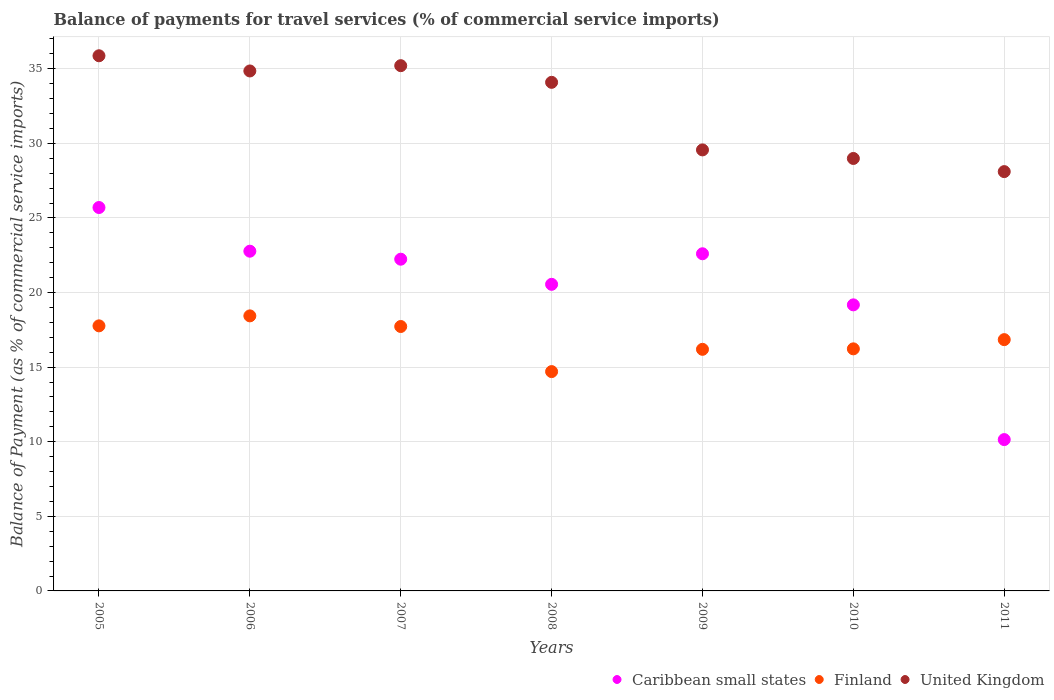How many different coloured dotlines are there?
Offer a terse response. 3. Is the number of dotlines equal to the number of legend labels?
Offer a terse response. Yes. What is the balance of payments for travel services in United Kingdom in 2006?
Ensure brevity in your answer.  34.86. Across all years, what is the maximum balance of payments for travel services in Caribbean small states?
Offer a terse response. 25.7. Across all years, what is the minimum balance of payments for travel services in Caribbean small states?
Your response must be concise. 10.14. In which year was the balance of payments for travel services in United Kingdom maximum?
Provide a short and direct response. 2005. What is the total balance of payments for travel services in United Kingdom in the graph?
Offer a very short reply. 226.7. What is the difference between the balance of payments for travel services in Finland in 2005 and that in 2008?
Your answer should be compact. 3.07. What is the difference between the balance of payments for travel services in Finland in 2006 and the balance of payments for travel services in Caribbean small states in 2010?
Offer a very short reply. -0.74. What is the average balance of payments for travel services in Finland per year?
Offer a very short reply. 16.84. In the year 2008, what is the difference between the balance of payments for travel services in Finland and balance of payments for travel services in United Kingdom?
Make the answer very short. -19.39. In how many years, is the balance of payments for travel services in Finland greater than 31 %?
Ensure brevity in your answer.  0. What is the ratio of the balance of payments for travel services in Caribbean small states in 2006 to that in 2010?
Provide a succinct answer. 1.19. What is the difference between the highest and the second highest balance of payments for travel services in United Kingdom?
Your answer should be compact. 0.66. What is the difference between the highest and the lowest balance of payments for travel services in Finland?
Ensure brevity in your answer.  3.74. In how many years, is the balance of payments for travel services in United Kingdom greater than the average balance of payments for travel services in United Kingdom taken over all years?
Ensure brevity in your answer.  4. Is the sum of the balance of payments for travel services in Caribbean small states in 2009 and 2010 greater than the maximum balance of payments for travel services in United Kingdom across all years?
Offer a very short reply. Yes. Does the balance of payments for travel services in United Kingdom monotonically increase over the years?
Make the answer very short. No. How many dotlines are there?
Offer a terse response. 3. Are the values on the major ticks of Y-axis written in scientific E-notation?
Make the answer very short. No. Does the graph contain grids?
Your answer should be compact. Yes. Where does the legend appear in the graph?
Provide a short and direct response. Bottom right. What is the title of the graph?
Provide a short and direct response. Balance of payments for travel services (% of commercial service imports). Does "Tajikistan" appear as one of the legend labels in the graph?
Your answer should be very brief. No. What is the label or title of the Y-axis?
Give a very brief answer. Balance of Payment (as % of commercial service imports). What is the Balance of Payment (as % of commercial service imports) of Caribbean small states in 2005?
Provide a short and direct response. 25.7. What is the Balance of Payment (as % of commercial service imports) in Finland in 2005?
Make the answer very short. 17.77. What is the Balance of Payment (as % of commercial service imports) of United Kingdom in 2005?
Provide a succinct answer. 35.87. What is the Balance of Payment (as % of commercial service imports) in Caribbean small states in 2006?
Ensure brevity in your answer.  22.77. What is the Balance of Payment (as % of commercial service imports) of Finland in 2006?
Keep it short and to the point. 18.44. What is the Balance of Payment (as % of commercial service imports) in United Kingdom in 2006?
Offer a terse response. 34.86. What is the Balance of Payment (as % of commercial service imports) in Caribbean small states in 2007?
Keep it short and to the point. 22.24. What is the Balance of Payment (as % of commercial service imports) of Finland in 2007?
Offer a terse response. 17.73. What is the Balance of Payment (as % of commercial service imports) in United Kingdom in 2007?
Offer a very short reply. 35.21. What is the Balance of Payment (as % of commercial service imports) of Caribbean small states in 2008?
Provide a short and direct response. 20.55. What is the Balance of Payment (as % of commercial service imports) in Finland in 2008?
Provide a succinct answer. 14.7. What is the Balance of Payment (as % of commercial service imports) in United Kingdom in 2008?
Your response must be concise. 34.09. What is the Balance of Payment (as % of commercial service imports) in Caribbean small states in 2009?
Make the answer very short. 22.6. What is the Balance of Payment (as % of commercial service imports) in Finland in 2009?
Provide a succinct answer. 16.2. What is the Balance of Payment (as % of commercial service imports) in United Kingdom in 2009?
Provide a short and direct response. 29.56. What is the Balance of Payment (as % of commercial service imports) in Caribbean small states in 2010?
Provide a succinct answer. 19.18. What is the Balance of Payment (as % of commercial service imports) of Finland in 2010?
Ensure brevity in your answer.  16.23. What is the Balance of Payment (as % of commercial service imports) in United Kingdom in 2010?
Ensure brevity in your answer.  28.99. What is the Balance of Payment (as % of commercial service imports) of Caribbean small states in 2011?
Give a very brief answer. 10.14. What is the Balance of Payment (as % of commercial service imports) of Finland in 2011?
Make the answer very short. 16.85. What is the Balance of Payment (as % of commercial service imports) of United Kingdom in 2011?
Ensure brevity in your answer.  28.11. Across all years, what is the maximum Balance of Payment (as % of commercial service imports) of Caribbean small states?
Offer a terse response. 25.7. Across all years, what is the maximum Balance of Payment (as % of commercial service imports) of Finland?
Give a very brief answer. 18.44. Across all years, what is the maximum Balance of Payment (as % of commercial service imports) in United Kingdom?
Your response must be concise. 35.87. Across all years, what is the minimum Balance of Payment (as % of commercial service imports) in Caribbean small states?
Give a very brief answer. 10.14. Across all years, what is the minimum Balance of Payment (as % of commercial service imports) in Finland?
Your answer should be very brief. 14.7. Across all years, what is the minimum Balance of Payment (as % of commercial service imports) in United Kingdom?
Ensure brevity in your answer.  28.11. What is the total Balance of Payment (as % of commercial service imports) of Caribbean small states in the graph?
Provide a short and direct response. 143.19. What is the total Balance of Payment (as % of commercial service imports) of Finland in the graph?
Your response must be concise. 117.9. What is the total Balance of Payment (as % of commercial service imports) in United Kingdom in the graph?
Offer a very short reply. 226.69. What is the difference between the Balance of Payment (as % of commercial service imports) of Caribbean small states in 2005 and that in 2006?
Offer a very short reply. 2.93. What is the difference between the Balance of Payment (as % of commercial service imports) of Finland in 2005 and that in 2006?
Provide a succinct answer. -0.67. What is the difference between the Balance of Payment (as % of commercial service imports) of United Kingdom in 2005 and that in 2006?
Your answer should be compact. 1.02. What is the difference between the Balance of Payment (as % of commercial service imports) in Caribbean small states in 2005 and that in 2007?
Provide a short and direct response. 3.46. What is the difference between the Balance of Payment (as % of commercial service imports) in Finland in 2005 and that in 2007?
Your answer should be compact. 0.04. What is the difference between the Balance of Payment (as % of commercial service imports) of United Kingdom in 2005 and that in 2007?
Your answer should be compact. 0.66. What is the difference between the Balance of Payment (as % of commercial service imports) of Caribbean small states in 2005 and that in 2008?
Offer a terse response. 5.15. What is the difference between the Balance of Payment (as % of commercial service imports) in Finland in 2005 and that in 2008?
Offer a terse response. 3.07. What is the difference between the Balance of Payment (as % of commercial service imports) in United Kingdom in 2005 and that in 2008?
Ensure brevity in your answer.  1.78. What is the difference between the Balance of Payment (as % of commercial service imports) in Caribbean small states in 2005 and that in 2009?
Your answer should be very brief. 3.1. What is the difference between the Balance of Payment (as % of commercial service imports) in Finland in 2005 and that in 2009?
Your response must be concise. 1.57. What is the difference between the Balance of Payment (as % of commercial service imports) in United Kingdom in 2005 and that in 2009?
Provide a short and direct response. 6.31. What is the difference between the Balance of Payment (as % of commercial service imports) of Caribbean small states in 2005 and that in 2010?
Provide a short and direct response. 6.53. What is the difference between the Balance of Payment (as % of commercial service imports) of Finland in 2005 and that in 2010?
Offer a very short reply. 1.54. What is the difference between the Balance of Payment (as % of commercial service imports) in United Kingdom in 2005 and that in 2010?
Your answer should be very brief. 6.88. What is the difference between the Balance of Payment (as % of commercial service imports) of Caribbean small states in 2005 and that in 2011?
Provide a short and direct response. 15.56. What is the difference between the Balance of Payment (as % of commercial service imports) of Finland in 2005 and that in 2011?
Offer a very short reply. 0.92. What is the difference between the Balance of Payment (as % of commercial service imports) in United Kingdom in 2005 and that in 2011?
Provide a succinct answer. 7.77. What is the difference between the Balance of Payment (as % of commercial service imports) of Caribbean small states in 2006 and that in 2007?
Offer a very short reply. 0.54. What is the difference between the Balance of Payment (as % of commercial service imports) in Finland in 2006 and that in 2007?
Make the answer very short. 0.71. What is the difference between the Balance of Payment (as % of commercial service imports) in United Kingdom in 2006 and that in 2007?
Provide a succinct answer. -0.35. What is the difference between the Balance of Payment (as % of commercial service imports) in Caribbean small states in 2006 and that in 2008?
Offer a very short reply. 2.22. What is the difference between the Balance of Payment (as % of commercial service imports) in Finland in 2006 and that in 2008?
Offer a very short reply. 3.74. What is the difference between the Balance of Payment (as % of commercial service imports) in United Kingdom in 2006 and that in 2008?
Make the answer very short. 0.76. What is the difference between the Balance of Payment (as % of commercial service imports) of Caribbean small states in 2006 and that in 2009?
Keep it short and to the point. 0.17. What is the difference between the Balance of Payment (as % of commercial service imports) of Finland in 2006 and that in 2009?
Offer a terse response. 2.24. What is the difference between the Balance of Payment (as % of commercial service imports) of United Kingdom in 2006 and that in 2009?
Ensure brevity in your answer.  5.29. What is the difference between the Balance of Payment (as % of commercial service imports) in Caribbean small states in 2006 and that in 2010?
Your response must be concise. 3.6. What is the difference between the Balance of Payment (as % of commercial service imports) of Finland in 2006 and that in 2010?
Your answer should be compact. 2.21. What is the difference between the Balance of Payment (as % of commercial service imports) in United Kingdom in 2006 and that in 2010?
Make the answer very short. 5.87. What is the difference between the Balance of Payment (as % of commercial service imports) in Caribbean small states in 2006 and that in 2011?
Offer a very short reply. 12.63. What is the difference between the Balance of Payment (as % of commercial service imports) in Finland in 2006 and that in 2011?
Your answer should be very brief. 1.59. What is the difference between the Balance of Payment (as % of commercial service imports) in United Kingdom in 2006 and that in 2011?
Give a very brief answer. 6.75. What is the difference between the Balance of Payment (as % of commercial service imports) in Caribbean small states in 2007 and that in 2008?
Your answer should be very brief. 1.68. What is the difference between the Balance of Payment (as % of commercial service imports) of Finland in 2007 and that in 2008?
Your response must be concise. 3.02. What is the difference between the Balance of Payment (as % of commercial service imports) of United Kingdom in 2007 and that in 2008?
Your answer should be compact. 1.12. What is the difference between the Balance of Payment (as % of commercial service imports) of Caribbean small states in 2007 and that in 2009?
Your answer should be very brief. -0.36. What is the difference between the Balance of Payment (as % of commercial service imports) of Finland in 2007 and that in 2009?
Offer a terse response. 1.53. What is the difference between the Balance of Payment (as % of commercial service imports) of United Kingdom in 2007 and that in 2009?
Make the answer very short. 5.65. What is the difference between the Balance of Payment (as % of commercial service imports) in Caribbean small states in 2007 and that in 2010?
Provide a short and direct response. 3.06. What is the difference between the Balance of Payment (as % of commercial service imports) of Finland in 2007 and that in 2010?
Make the answer very short. 1.5. What is the difference between the Balance of Payment (as % of commercial service imports) in United Kingdom in 2007 and that in 2010?
Offer a terse response. 6.22. What is the difference between the Balance of Payment (as % of commercial service imports) in Caribbean small states in 2007 and that in 2011?
Provide a short and direct response. 12.09. What is the difference between the Balance of Payment (as % of commercial service imports) of Finland in 2007 and that in 2011?
Make the answer very short. 0.88. What is the difference between the Balance of Payment (as % of commercial service imports) in United Kingdom in 2007 and that in 2011?
Provide a short and direct response. 7.1. What is the difference between the Balance of Payment (as % of commercial service imports) in Caribbean small states in 2008 and that in 2009?
Give a very brief answer. -2.05. What is the difference between the Balance of Payment (as % of commercial service imports) of Finland in 2008 and that in 2009?
Keep it short and to the point. -1.49. What is the difference between the Balance of Payment (as % of commercial service imports) of United Kingdom in 2008 and that in 2009?
Your response must be concise. 4.53. What is the difference between the Balance of Payment (as % of commercial service imports) in Caribbean small states in 2008 and that in 2010?
Provide a succinct answer. 1.38. What is the difference between the Balance of Payment (as % of commercial service imports) in Finland in 2008 and that in 2010?
Your response must be concise. -1.53. What is the difference between the Balance of Payment (as % of commercial service imports) in United Kingdom in 2008 and that in 2010?
Give a very brief answer. 5.1. What is the difference between the Balance of Payment (as % of commercial service imports) in Caribbean small states in 2008 and that in 2011?
Ensure brevity in your answer.  10.41. What is the difference between the Balance of Payment (as % of commercial service imports) of Finland in 2008 and that in 2011?
Your answer should be very brief. -2.14. What is the difference between the Balance of Payment (as % of commercial service imports) of United Kingdom in 2008 and that in 2011?
Your answer should be very brief. 5.98. What is the difference between the Balance of Payment (as % of commercial service imports) of Caribbean small states in 2009 and that in 2010?
Your response must be concise. 3.42. What is the difference between the Balance of Payment (as % of commercial service imports) of Finland in 2009 and that in 2010?
Provide a short and direct response. -0.03. What is the difference between the Balance of Payment (as % of commercial service imports) in United Kingdom in 2009 and that in 2010?
Your answer should be very brief. 0.57. What is the difference between the Balance of Payment (as % of commercial service imports) of Caribbean small states in 2009 and that in 2011?
Provide a succinct answer. 12.46. What is the difference between the Balance of Payment (as % of commercial service imports) in Finland in 2009 and that in 2011?
Provide a succinct answer. -0.65. What is the difference between the Balance of Payment (as % of commercial service imports) of United Kingdom in 2009 and that in 2011?
Offer a very short reply. 1.46. What is the difference between the Balance of Payment (as % of commercial service imports) in Caribbean small states in 2010 and that in 2011?
Provide a short and direct response. 9.03. What is the difference between the Balance of Payment (as % of commercial service imports) of Finland in 2010 and that in 2011?
Make the answer very short. -0.62. What is the difference between the Balance of Payment (as % of commercial service imports) of United Kingdom in 2010 and that in 2011?
Make the answer very short. 0.88. What is the difference between the Balance of Payment (as % of commercial service imports) in Caribbean small states in 2005 and the Balance of Payment (as % of commercial service imports) in Finland in 2006?
Keep it short and to the point. 7.26. What is the difference between the Balance of Payment (as % of commercial service imports) in Caribbean small states in 2005 and the Balance of Payment (as % of commercial service imports) in United Kingdom in 2006?
Your response must be concise. -9.15. What is the difference between the Balance of Payment (as % of commercial service imports) of Finland in 2005 and the Balance of Payment (as % of commercial service imports) of United Kingdom in 2006?
Offer a terse response. -17.09. What is the difference between the Balance of Payment (as % of commercial service imports) in Caribbean small states in 2005 and the Balance of Payment (as % of commercial service imports) in Finland in 2007?
Your answer should be compact. 7.98. What is the difference between the Balance of Payment (as % of commercial service imports) of Caribbean small states in 2005 and the Balance of Payment (as % of commercial service imports) of United Kingdom in 2007?
Give a very brief answer. -9.51. What is the difference between the Balance of Payment (as % of commercial service imports) of Finland in 2005 and the Balance of Payment (as % of commercial service imports) of United Kingdom in 2007?
Your answer should be very brief. -17.44. What is the difference between the Balance of Payment (as % of commercial service imports) in Caribbean small states in 2005 and the Balance of Payment (as % of commercial service imports) in Finland in 2008?
Offer a very short reply. 11. What is the difference between the Balance of Payment (as % of commercial service imports) of Caribbean small states in 2005 and the Balance of Payment (as % of commercial service imports) of United Kingdom in 2008?
Offer a very short reply. -8.39. What is the difference between the Balance of Payment (as % of commercial service imports) in Finland in 2005 and the Balance of Payment (as % of commercial service imports) in United Kingdom in 2008?
Your response must be concise. -16.32. What is the difference between the Balance of Payment (as % of commercial service imports) in Caribbean small states in 2005 and the Balance of Payment (as % of commercial service imports) in Finland in 2009?
Offer a very short reply. 9.51. What is the difference between the Balance of Payment (as % of commercial service imports) of Caribbean small states in 2005 and the Balance of Payment (as % of commercial service imports) of United Kingdom in 2009?
Offer a terse response. -3.86. What is the difference between the Balance of Payment (as % of commercial service imports) of Finland in 2005 and the Balance of Payment (as % of commercial service imports) of United Kingdom in 2009?
Make the answer very short. -11.79. What is the difference between the Balance of Payment (as % of commercial service imports) in Caribbean small states in 2005 and the Balance of Payment (as % of commercial service imports) in Finland in 2010?
Make the answer very short. 9.47. What is the difference between the Balance of Payment (as % of commercial service imports) of Caribbean small states in 2005 and the Balance of Payment (as % of commercial service imports) of United Kingdom in 2010?
Your response must be concise. -3.29. What is the difference between the Balance of Payment (as % of commercial service imports) in Finland in 2005 and the Balance of Payment (as % of commercial service imports) in United Kingdom in 2010?
Keep it short and to the point. -11.22. What is the difference between the Balance of Payment (as % of commercial service imports) in Caribbean small states in 2005 and the Balance of Payment (as % of commercial service imports) in Finland in 2011?
Make the answer very short. 8.86. What is the difference between the Balance of Payment (as % of commercial service imports) in Caribbean small states in 2005 and the Balance of Payment (as % of commercial service imports) in United Kingdom in 2011?
Your answer should be very brief. -2.41. What is the difference between the Balance of Payment (as % of commercial service imports) of Finland in 2005 and the Balance of Payment (as % of commercial service imports) of United Kingdom in 2011?
Your answer should be compact. -10.34. What is the difference between the Balance of Payment (as % of commercial service imports) in Caribbean small states in 2006 and the Balance of Payment (as % of commercial service imports) in Finland in 2007?
Your answer should be very brief. 5.05. What is the difference between the Balance of Payment (as % of commercial service imports) in Caribbean small states in 2006 and the Balance of Payment (as % of commercial service imports) in United Kingdom in 2007?
Offer a terse response. -12.44. What is the difference between the Balance of Payment (as % of commercial service imports) of Finland in 2006 and the Balance of Payment (as % of commercial service imports) of United Kingdom in 2007?
Provide a succinct answer. -16.77. What is the difference between the Balance of Payment (as % of commercial service imports) of Caribbean small states in 2006 and the Balance of Payment (as % of commercial service imports) of Finland in 2008?
Keep it short and to the point. 8.07. What is the difference between the Balance of Payment (as % of commercial service imports) in Caribbean small states in 2006 and the Balance of Payment (as % of commercial service imports) in United Kingdom in 2008?
Your answer should be very brief. -11.32. What is the difference between the Balance of Payment (as % of commercial service imports) in Finland in 2006 and the Balance of Payment (as % of commercial service imports) in United Kingdom in 2008?
Your answer should be compact. -15.66. What is the difference between the Balance of Payment (as % of commercial service imports) in Caribbean small states in 2006 and the Balance of Payment (as % of commercial service imports) in Finland in 2009?
Ensure brevity in your answer.  6.58. What is the difference between the Balance of Payment (as % of commercial service imports) of Caribbean small states in 2006 and the Balance of Payment (as % of commercial service imports) of United Kingdom in 2009?
Your response must be concise. -6.79. What is the difference between the Balance of Payment (as % of commercial service imports) of Finland in 2006 and the Balance of Payment (as % of commercial service imports) of United Kingdom in 2009?
Offer a very short reply. -11.13. What is the difference between the Balance of Payment (as % of commercial service imports) in Caribbean small states in 2006 and the Balance of Payment (as % of commercial service imports) in Finland in 2010?
Ensure brevity in your answer.  6.55. What is the difference between the Balance of Payment (as % of commercial service imports) of Caribbean small states in 2006 and the Balance of Payment (as % of commercial service imports) of United Kingdom in 2010?
Offer a terse response. -6.22. What is the difference between the Balance of Payment (as % of commercial service imports) of Finland in 2006 and the Balance of Payment (as % of commercial service imports) of United Kingdom in 2010?
Offer a very short reply. -10.55. What is the difference between the Balance of Payment (as % of commercial service imports) of Caribbean small states in 2006 and the Balance of Payment (as % of commercial service imports) of Finland in 2011?
Make the answer very short. 5.93. What is the difference between the Balance of Payment (as % of commercial service imports) in Caribbean small states in 2006 and the Balance of Payment (as % of commercial service imports) in United Kingdom in 2011?
Offer a terse response. -5.33. What is the difference between the Balance of Payment (as % of commercial service imports) of Finland in 2006 and the Balance of Payment (as % of commercial service imports) of United Kingdom in 2011?
Your answer should be very brief. -9.67. What is the difference between the Balance of Payment (as % of commercial service imports) in Caribbean small states in 2007 and the Balance of Payment (as % of commercial service imports) in Finland in 2008?
Provide a short and direct response. 7.53. What is the difference between the Balance of Payment (as % of commercial service imports) of Caribbean small states in 2007 and the Balance of Payment (as % of commercial service imports) of United Kingdom in 2008?
Your response must be concise. -11.86. What is the difference between the Balance of Payment (as % of commercial service imports) in Finland in 2007 and the Balance of Payment (as % of commercial service imports) in United Kingdom in 2008?
Provide a succinct answer. -16.37. What is the difference between the Balance of Payment (as % of commercial service imports) in Caribbean small states in 2007 and the Balance of Payment (as % of commercial service imports) in Finland in 2009?
Your answer should be compact. 6.04. What is the difference between the Balance of Payment (as % of commercial service imports) of Caribbean small states in 2007 and the Balance of Payment (as % of commercial service imports) of United Kingdom in 2009?
Your answer should be compact. -7.33. What is the difference between the Balance of Payment (as % of commercial service imports) in Finland in 2007 and the Balance of Payment (as % of commercial service imports) in United Kingdom in 2009?
Your response must be concise. -11.84. What is the difference between the Balance of Payment (as % of commercial service imports) of Caribbean small states in 2007 and the Balance of Payment (as % of commercial service imports) of Finland in 2010?
Provide a short and direct response. 6.01. What is the difference between the Balance of Payment (as % of commercial service imports) of Caribbean small states in 2007 and the Balance of Payment (as % of commercial service imports) of United Kingdom in 2010?
Give a very brief answer. -6.75. What is the difference between the Balance of Payment (as % of commercial service imports) of Finland in 2007 and the Balance of Payment (as % of commercial service imports) of United Kingdom in 2010?
Make the answer very short. -11.26. What is the difference between the Balance of Payment (as % of commercial service imports) in Caribbean small states in 2007 and the Balance of Payment (as % of commercial service imports) in Finland in 2011?
Ensure brevity in your answer.  5.39. What is the difference between the Balance of Payment (as % of commercial service imports) in Caribbean small states in 2007 and the Balance of Payment (as % of commercial service imports) in United Kingdom in 2011?
Make the answer very short. -5.87. What is the difference between the Balance of Payment (as % of commercial service imports) of Finland in 2007 and the Balance of Payment (as % of commercial service imports) of United Kingdom in 2011?
Provide a succinct answer. -10.38. What is the difference between the Balance of Payment (as % of commercial service imports) of Caribbean small states in 2008 and the Balance of Payment (as % of commercial service imports) of Finland in 2009?
Provide a succinct answer. 4.36. What is the difference between the Balance of Payment (as % of commercial service imports) in Caribbean small states in 2008 and the Balance of Payment (as % of commercial service imports) in United Kingdom in 2009?
Offer a very short reply. -9.01. What is the difference between the Balance of Payment (as % of commercial service imports) in Finland in 2008 and the Balance of Payment (as % of commercial service imports) in United Kingdom in 2009?
Your answer should be compact. -14.86. What is the difference between the Balance of Payment (as % of commercial service imports) in Caribbean small states in 2008 and the Balance of Payment (as % of commercial service imports) in Finland in 2010?
Your answer should be very brief. 4.32. What is the difference between the Balance of Payment (as % of commercial service imports) in Caribbean small states in 2008 and the Balance of Payment (as % of commercial service imports) in United Kingdom in 2010?
Ensure brevity in your answer.  -8.44. What is the difference between the Balance of Payment (as % of commercial service imports) in Finland in 2008 and the Balance of Payment (as % of commercial service imports) in United Kingdom in 2010?
Provide a succinct answer. -14.29. What is the difference between the Balance of Payment (as % of commercial service imports) of Caribbean small states in 2008 and the Balance of Payment (as % of commercial service imports) of Finland in 2011?
Offer a very short reply. 3.71. What is the difference between the Balance of Payment (as % of commercial service imports) of Caribbean small states in 2008 and the Balance of Payment (as % of commercial service imports) of United Kingdom in 2011?
Ensure brevity in your answer.  -7.56. What is the difference between the Balance of Payment (as % of commercial service imports) of Finland in 2008 and the Balance of Payment (as % of commercial service imports) of United Kingdom in 2011?
Ensure brevity in your answer.  -13.41. What is the difference between the Balance of Payment (as % of commercial service imports) in Caribbean small states in 2009 and the Balance of Payment (as % of commercial service imports) in Finland in 2010?
Offer a very short reply. 6.37. What is the difference between the Balance of Payment (as % of commercial service imports) in Caribbean small states in 2009 and the Balance of Payment (as % of commercial service imports) in United Kingdom in 2010?
Keep it short and to the point. -6.39. What is the difference between the Balance of Payment (as % of commercial service imports) in Finland in 2009 and the Balance of Payment (as % of commercial service imports) in United Kingdom in 2010?
Offer a terse response. -12.79. What is the difference between the Balance of Payment (as % of commercial service imports) of Caribbean small states in 2009 and the Balance of Payment (as % of commercial service imports) of Finland in 2011?
Your answer should be very brief. 5.76. What is the difference between the Balance of Payment (as % of commercial service imports) of Caribbean small states in 2009 and the Balance of Payment (as % of commercial service imports) of United Kingdom in 2011?
Provide a succinct answer. -5.51. What is the difference between the Balance of Payment (as % of commercial service imports) of Finland in 2009 and the Balance of Payment (as % of commercial service imports) of United Kingdom in 2011?
Ensure brevity in your answer.  -11.91. What is the difference between the Balance of Payment (as % of commercial service imports) in Caribbean small states in 2010 and the Balance of Payment (as % of commercial service imports) in Finland in 2011?
Ensure brevity in your answer.  2.33. What is the difference between the Balance of Payment (as % of commercial service imports) of Caribbean small states in 2010 and the Balance of Payment (as % of commercial service imports) of United Kingdom in 2011?
Your response must be concise. -8.93. What is the difference between the Balance of Payment (as % of commercial service imports) of Finland in 2010 and the Balance of Payment (as % of commercial service imports) of United Kingdom in 2011?
Provide a short and direct response. -11.88. What is the average Balance of Payment (as % of commercial service imports) of Caribbean small states per year?
Your answer should be compact. 20.46. What is the average Balance of Payment (as % of commercial service imports) in Finland per year?
Offer a terse response. 16.84. What is the average Balance of Payment (as % of commercial service imports) in United Kingdom per year?
Make the answer very short. 32.38. In the year 2005, what is the difference between the Balance of Payment (as % of commercial service imports) of Caribbean small states and Balance of Payment (as % of commercial service imports) of Finland?
Your answer should be compact. 7.93. In the year 2005, what is the difference between the Balance of Payment (as % of commercial service imports) of Caribbean small states and Balance of Payment (as % of commercial service imports) of United Kingdom?
Provide a succinct answer. -10.17. In the year 2005, what is the difference between the Balance of Payment (as % of commercial service imports) of Finland and Balance of Payment (as % of commercial service imports) of United Kingdom?
Your response must be concise. -18.11. In the year 2006, what is the difference between the Balance of Payment (as % of commercial service imports) in Caribbean small states and Balance of Payment (as % of commercial service imports) in Finland?
Your answer should be very brief. 4.34. In the year 2006, what is the difference between the Balance of Payment (as % of commercial service imports) in Caribbean small states and Balance of Payment (as % of commercial service imports) in United Kingdom?
Your response must be concise. -12.08. In the year 2006, what is the difference between the Balance of Payment (as % of commercial service imports) in Finland and Balance of Payment (as % of commercial service imports) in United Kingdom?
Give a very brief answer. -16.42. In the year 2007, what is the difference between the Balance of Payment (as % of commercial service imports) of Caribbean small states and Balance of Payment (as % of commercial service imports) of Finland?
Keep it short and to the point. 4.51. In the year 2007, what is the difference between the Balance of Payment (as % of commercial service imports) of Caribbean small states and Balance of Payment (as % of commercial service imports) of United Kingdom?
Ensure brevity in your answer.  -12.97. In the year 2007, what is the difference between the Balance of Payment (as % of commercial service imports) in Finland and Balance of Payment (as % of commercial service imports) in United Kingdom?
Ensure brevity in your answer.  -17.48. In the year 2008, what is the difference between the Balance of Payment (as % of commercial service imports) of Caribbean small states and Balance of Payment (as % of commercial service imports) of Finland?
Make the answer very short. 5.85. In the year 2008, what is the difference between the Balance of Payment (as % of commercial service imports) in Caribbean small states and Balance of Payment (as % of commercial service imports) in United Kingdom?
Your answer should be compact. -13.54. In the year 2008, what is the difference between the Balance of Payment (as % of commercial service imports) in Finland and Balance of Payment (as % of commercial service imports) in United Kingdom?
Offer a terse response. -19.39. In the year 2009, what is the difference between the Balance of Payment (as % of commercial service imports) of Caribbean small states and Balance of Payment (as % of commercial service imports) of Finland?
Your answer should be compact. 6.41. In the year 2009, what is the difference between the Balance of Payment (as % of commercial service imports) of Caribbean small states and Balance of Payment (as % of commercial service imports) of United Kingdom?
Your response must be concise. -6.96. In the year 2009, what is the difference between the Balance of Payment (as % of commercial service imports) of Finland and Balance of Payment (as % of commercial service imports) of United Kingdom?
Offer a very short reply. -13.37. In the year 2010, what is the difference between the Balance of Payment (as % of commercial service imports) in Caribbean small states and Balance of Payment (as % of commercial service imports) in Finland?
Make the answer very short. 2.95. In the year 2010, what is the difference between the Balance of Payment (as % of commercial service imports) in Caribbean small states and Balance of Payment (as % of commercial service imports) in United Kingdom?
Make the answer very short. -9.81. In the year 2010, what is the difference between the Balance of Payment (as % of commercial service imports) of Finland and Balance of Payment (as % of commercial service imports) of United Kingdom?
Keep it short and to the point. -12.76. In the year 2011, what is the difference between the Balance of Payment (as % of commercial service imports) of Caribbean small states and Balance of Payment (as % of commercial service imports) of Finland?
Your answer should be very brief. -6.7. In the year 2011, what is the difference between the Balance of Payment (as % of commercial service imports) of Caribbean small states and Balance of Payment (as % of commercial service imports) of United Kingdom?
Give a very brief answer. -17.96. In the year 2011, what is the difference between the Balance of Payment (as % of commercial service imports) of Finland and Balance of Payment (as % of commercial service imports) of United Kingdom?
Ensure brevity in your answer.  -11.26. What is the ratio of the Balance of Payment (as % of commercial service imports) in Caribbean small states in 2005 to that in 2006?
Offer a very short reply. 1.13. What is the ratio of the Balance of Payment (as % of commercial service imports) of Finland in 2005 to that in 2006?
Your answer should be compact. 0.96. What is the ratio of the Balance of Payment (as % of commercial service imports) of United Kingdom in 2005 to that in 2006?
Give a very brief answer. 1.03. What is the ratio of the Balance of Payment (as % of commercial service imports) of Caribbean small states in 2005 to that in 2007?
Keep it short and to the point. 1.16. What is the ratio of the Balance of Payment (as % of commercial service imports) of Finland in 2005 to that in 2007?
Offer a terse response. 1. What is the ratio of the Balance of Payment (as % of commercial service imports) of United Kingdom in 2005 to that in 2007?
Your response must be concise. 1.02. What is the ratio of the Balance of Payment (as % of commercial service imports) of Caribbean small states in 2005 to that in 2008?
Give a very brief answer. 1.25. What is the ratio of the Balance of Payment (as % of commercial service imports) of Finland in 2005 to that in 2008?
Keep it short and to the point. 1.21. What is the ratio of the Balance of Payment (as % of commercial service imports) in United Kingdom in 2005 to that in 2008?
Offer a terse response. 1.05. What is the ratio of the Balance of Payment (as % of commercial service imports) of Caribbean small states in 2005 to that in 2009?
Offer a very short reply. 1.14. What is the ratio of the Balance of Payment (as % of commercial service imports) in Finland in 2005 to that in 2009?
Ensure brevity in your answer.  1.1. What is the ratio of the Balance of Payment (as % of commercial service imports) of United Kingdom in 2005 to that in 2009?
Provide a short and direct response. 1.21. What is the ratio of the Balance of Payment (as % of commercial service imports) of Caribbean small states in 2005 to that in 2010?
Your answer should be very brief. 1.34. What is the ratio of the Balance of Payment (as % of commercial service imports) of Finland in 2005 to that in 2010?
Provide a succinct answer. 1.09. What is the ratio of the Balance of Payment (as % of commercial service imports) in United Kingdom in 2005 to that in 2010?
Provide a succinct answer. 1.24. What is the ratio of the Balance of Payment (as % of commercial service imports) of Caribbean small states in 2005 to that in 2011?
Keep it short and to the point. 2.53. What is the ratio of the Balance of Payment (as % of commercial service imports) in Finland in 2005 to that in 2011?
Offer a very short reply. 1.05. What is the ratio of the Balance of Payment (as % of commercial service imports) of United Kingdom in 2005 to that in 2011?
Offer a very short reply. 1.28. What is the ratio of the Balance of Payment (as % of commercial service imports) in Caribbean small states in 2006 to that in 2007?
Make the answer very short. 1.02. What is the ratio of the Balance of Payment (as % of commercial service imports) in Finland in 2006 to that in 2007?
Your answer should be very brief. 1.04. What is the ratio of the Balance of Payment (as % of commercial service imports) in Caribbean small states in 2006 to that in 2008?
Make the answer very short. 1.11. What is the ratio of the Balance of Payment (as % of commercial service imports) in Finland in 2006 to that in 2008?
Your response must be concise. 1.25. What is the ratio of the Balance of Payment (as % of commercial service imports) in United Kingdom in 2006 to that in 2008?
Your answer should be very brief. 1.02. What is the ratio of the Balance of Payment (as % of commercial service imports) in Caribbean small states in 2006 to that in 2009?
Offer a terse response. 1.01. What is the ratio of the Balance of Payment (as % of commercial service imports) of Finland in 2006 to that in 2009?
Provide a short and direct response. 1.14. What is the ratio of the Balance of Payment (as % of commercial service imports) in United Kingdom in 2006 to that in 2009?
Your response must be concise. 1.18. What is the ratio of the Balance of Payment (as % of commercial service imports) of Caribbean small states in 2006 to that in 2010?
Offer a very short reply. 1.19. What is the ratio of the Balance of Payment (as % of commercial service imports) of Finland in 2006 to that in 2010?
Ensure brevity in your answer.  1.14. What is the ratio of the Balance of Payment (as % of commercial service imports) of United Kingdom in 2006 to that in 2010?
Keep it short and to the point. 1.2. What is the ratio of the Balance of Payment (as % of commercial service imports) of Caribbean small states in 2006 to that in 2011?
Your answer should be compact. 2.24. What is the ratio of the Balance of Payment (as % of commercial service imports) in Finland in 2006 to that in 2011?
Provide a short and direct response. 1.09. What is the ratio of the Balance of Payment (as % of commercial service imports) of United Kingdom in 2006 to that in 2011?
Offer a very short reply. 1.24. What is the ratio of the Balance of Payment (as % of commercial service imports) of Caribbean small states in 2007 to that in 2008?
Keep it short and to the point. 1.08. What is the ratio of the Balance of Payment (as % of commercial service imports) of Finland in 2007 to that in 2008?
Your response must be concise. 1.21. What is the ratio of the Balance of Payment (as % of commercial service imports) in United Kingdom in 2007 to that in 2008?
Ensure brevity in your answer.  1.03. What is the ratio of the Balance of Payment (as % of commercial service imports) of Caribbean small states in 2007 to that in 2009?
Your response must be concise. 0.98. What is the ratio of the Balance of Payment (as % of commercial service imports) of Finland in 2007 to that in 2009?
Your answer should be very brief. 1.09. What is the ratio of the Balance of Payment (as % of commercial service imports) of United Kingdom in 2007 to that in 2009?
Keep it short and to the point. 1.19. What is the ratio of the Balance of Payment (as % of commercial service imports) of Caribbean small states in 2007 to that in 2010?
Offer a very short reply. 1.16. What is the ratio of the Balance of Payment (as % of commercial service imports) in Finland in 2007 to that in 2010?
Your answer should be very brief. 1.09. What is the ratio of the Balance of Payment (as % of commercial service imports) of United Kingdom in 2007 to that in 2010?
Provide a short and direct response. 1.21. What is the ratio of the Balance of Payment (as % of commercial service imports) in Caribbean small states in 2007 to that in 2011?
Give a very brief answer. 2.19. What is the ratio of the Balance of Payment (as % of commercial service imports) in Finland in 2007 to that in 2011?
Give a very brief answer. 1.05. What is the ratio of the Balance of Payment (as % of commercial service imports) in United Kingdom in 2007 to that in 2011?
Your response must be concise. 1.25. What is the ratio of the Balance of Payment (as % of commercial service imports) of Caribbean small states in 2008 to that in 2009?
Keep it short and to the point. 0.91. What is the ratio of the Balance of Payment (as % of commercial service imports) of Finland in 2008 to that in 2009?
Your response must be concise. 0.91. What is the ratio of the Balance of Payment (as % of commercial service imports) of United Kingdom in 2008 to that in 2009?
Your response must be concise. 1.15. What is the ratio of the Balance of Payment (as % of commercial service imports) of Caribbean small states in 2008 to that in 2010?
Provide a succinct answer. 1.07. What is the ratio of the Balance of Payment (as % of commercial service imports) in Finland in 2008 to that in 2010?
Offer a very short reply. 0.91. What is the ratio of the Balance of Payment (as % of commercial service imports) in United Kingdom in 2008 to that in 2010?
Provide a short and direct response. 1.18. What is the ratio of the Balance of Payment (as % of commercial service imports) of Caribbean small states in 2008 to that in 2011?
Make the answer very short. 2.03. What is the ratio of the Balance of Payment (as % of commercial service imports) in Finland in 2008 to that in 2011?
Your response must be concise. 0.87. What is the ratio of the Balance of Payment (as % of commercial service imports) in United Kingdom in 2008 to that in 2011?
Offer a very short reply. 1.21. What is the ratio of the Balance of Payment (as % of commercial service imports) of Caribbean small states in 2009 to that in 2010?
Your answer should be very brief. 1.18. What is the ratio of the Balance of Payment (as % of commercial service imports) of Finland in 2009 to that in 2010?
Your answer should be very brief. 1. What is the ratio of the Balance of Payment (as % of commercial service imports) in United Kingdom in 2009 to that in 2010?
Provide a short and direct response. 1.02. What is the ratio of the Balance of Payment (as % of commercial service imports) of Caribbean small states in 2009 to that in 2011?
Your response must be concise. 2.23. What is the ratio of the Balance of Payment (as % of commercial service imports) of Finland in 2009 to that in 2011?
Provide a short and direct response. 0.96. What is the ratio of the Balance of Payment (as % of commercial service imports) of United Kingdom in 2009 to that in 2011?
Make the answer very short. 1.05. What is the ratio of the Balance of Payment (as % of commercial service imports) of Caribbean small states in 2010 to that in 2011?
Offer a very short reply. 1.89. What is the ratio of the Balance of Payment (as % of commercial service imports) of Finland in 2010 to that in 2011?
Keep it short and to the point. 0.96. What is the ratio of the Balance of Payment (as % of commercial service imports) of United Kingdom in 2010 to that in 2011?
Your response must be concise. 1.03. What is the difference between the highest and the second highest Balance of Payment (as % of commercial service imports) in Caribbean small states?
Offer a terse response. 2.93. What is the difference between the highest and the second highest Balance of Payment (as % of commercial service imports) of Finland?
Make the answer very short. 0.67. What is the difference between the highest and the second highest Balance of Payment (as % of commercial service imports) of United Kingdom?
Provide a short and direct response. 0.66. What is the difference between the highest and the lowest Balance of Payment (as % of commercial service imports) of Caribbean small states?
Give a very brief answer. 15.56. What is the difference between the highest and the lowest Balance of Payment (as % of commercial service imports) in Finland?
Offer a very short reply. 3.74. What is the difference between the highest and the lowest Balance of Payment (as % of commercial service imports) of United Kingdom?
Provide a succinct answer. 7.77. 